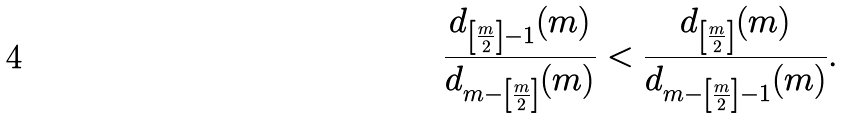Convert formula to latex. <formula><loc_0><loc_0><loc_500><loc_500>\frac { d _ { \left [ \frac { m } { 2 } \right ] - 1 } ( m ) } { d _ { m - \left [ \frac { m } { 2 } \right ] } ( m ) } < \frac { d _ { \left [ \frac { m } { 2 } \right ] } ( m ) } { d _ { m - \left [ \frac { m } { 2 } \right ] - 1 } ( m ) } .</formula> 